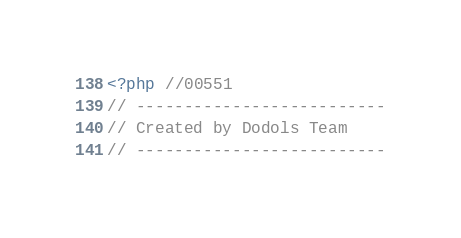<code> <loc_0><loc_0><loc_500><loc_500><_PHP_><?php //00551
// --------------------------
// Created by Dodols Team
// --------------------------</code> 